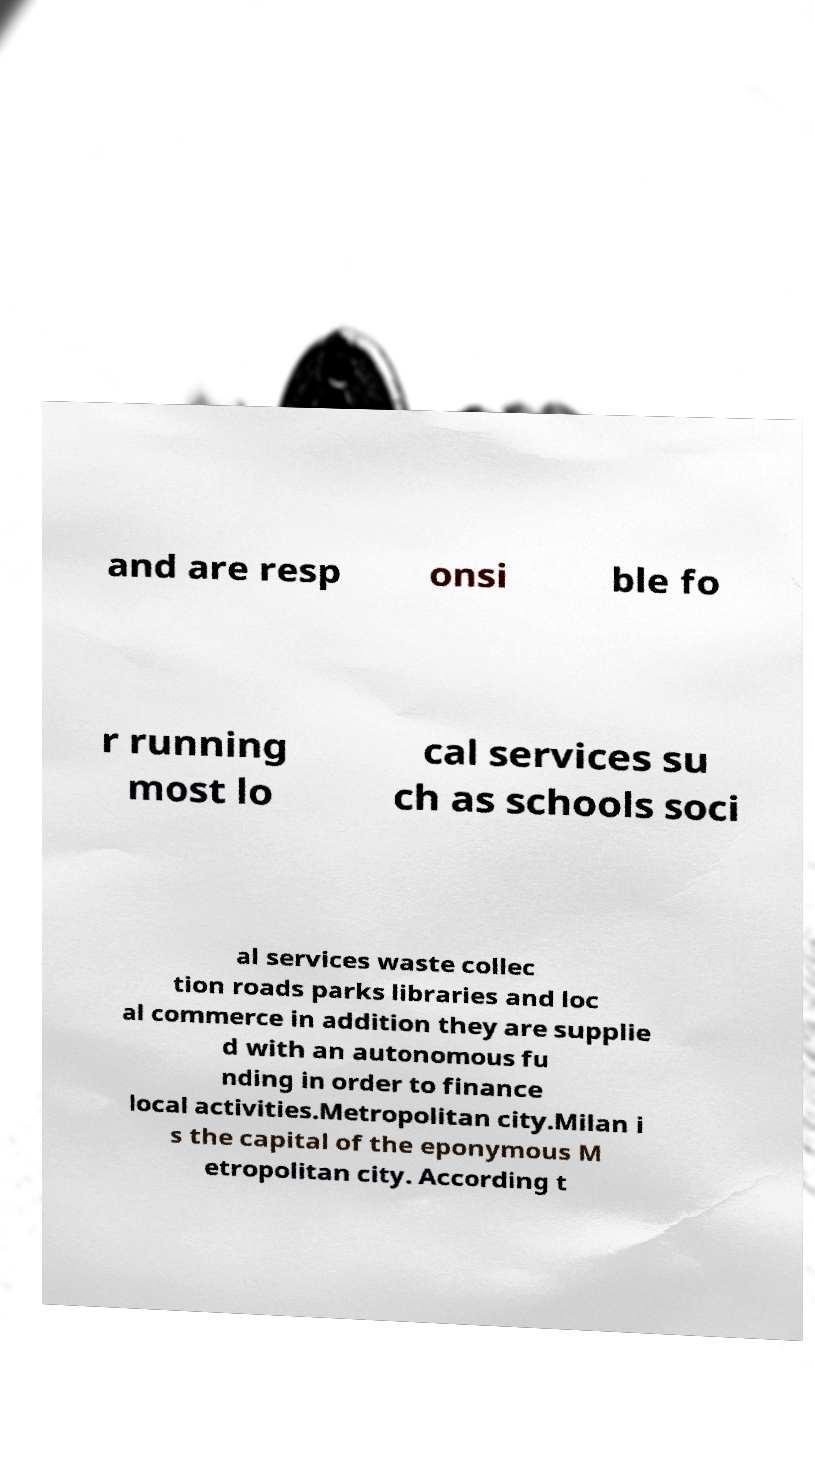What messages or text are displayed in this image? I need them in a readable, typed format. and are resp onsi ble fo r running most lo cal services su ch as schools soci al services waste collec tion roads parks libraries and loc al commerce in addition they are supplie d with an autonomous fu nding in order to finance local activities.Metropolitan city.Milan i s the capital of the eponymous M etropolitan city. According t 